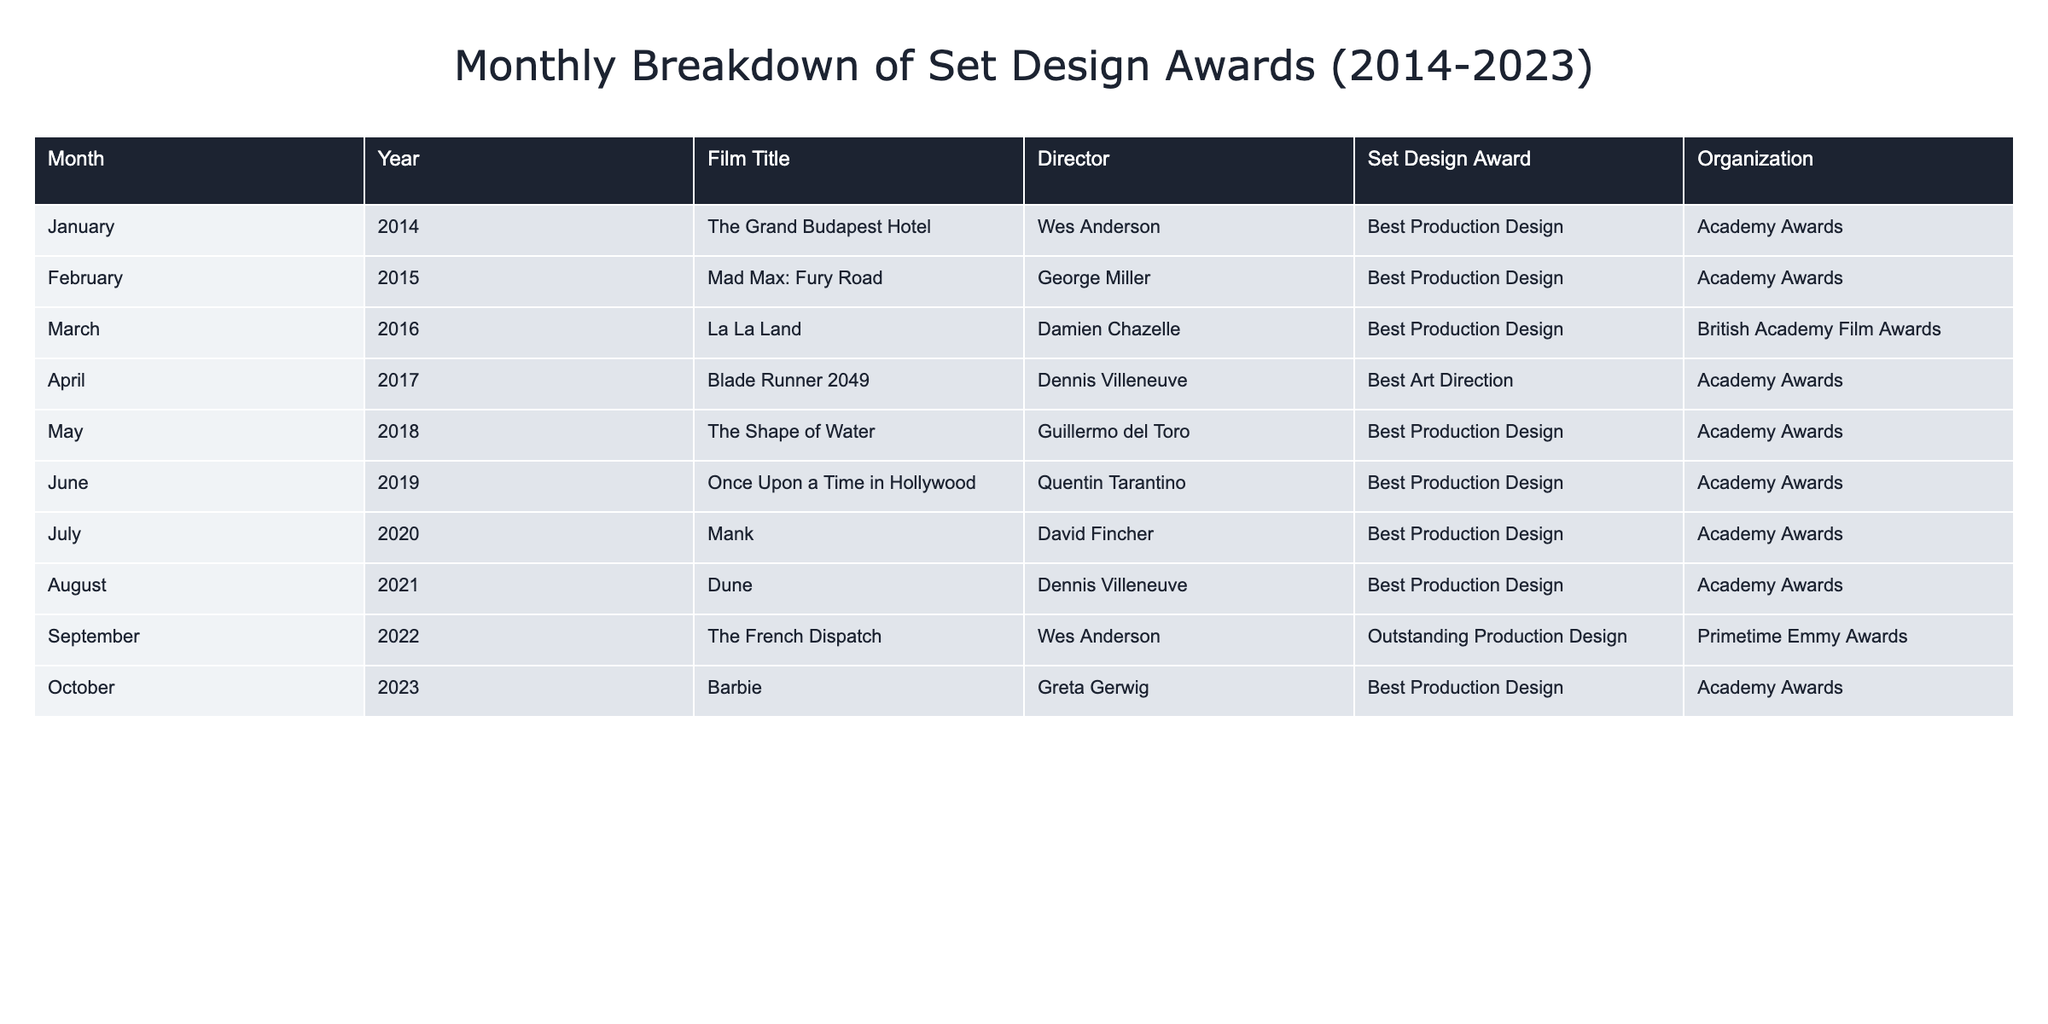What film won the Best Production Design award in February 2015? The table indicates that the film "Mad Max: Fury Road" directed by George Miller won the Best Production Design award in February 2015, according to the Academy Awards.
Answer: Mad Max: Fury Road How many films won set design awards in 2018? From the table, we see that only one film, "The Shape of Water" directed by Guillermo del Toro, won a set design award in 2018, recognized by the Academy Awards.
Answer: 1 Which director has won the most set design awards from the table provided? By reviewing the table, Wes Anderson has won two distinct awards for set design: one for "The Grand Budapest Hotel" in 2014 and another for "The French Dispatch" in 2022. No other director has won more than one award listed in this table.
Answer: Wes Anderson What is the total number of awards won through the Academy Awards for Best Production Design in the last decade? The Academy Awards granted Best Production Design awards to the films "The Grand Budapest Hotel," "Mad Max: Fury Road," "La La Land," "Blade Runner 2049," "The Shape of Water," "Once Upon a Time in Hollywood," "Mank," "Dune," and "Barbie." Counting these gives us eight awards total.
Answer: 8 Was there a set design award given by the Primetime Emmy Awards? Yes, the table shows that "The French Dispatch," directed by Wes Anderson, received the Outstanding Production Design award from the Primetime Emmy Awards in September 2022, indicating that Primetime Emmy Awards do recognize set design.
Answer: Yes What was the latest year represented in the table for the Best Production Design award? The table lists "Barbie," directed by Greta Gerwig, which won the Best Production Design award in October 2023, making it the latest year included in this breakdown.
Answer: 2023 How many different organizations awarded set design awards over the decade? Counting distinct organizations from the table, we see three award bodies: the Academy Awards, the British Academy Film Awards, and the Primetime Emmy Awards. Hence, there are three unique awarding organizations.
Answer: 3 Which film won an award for set design in 2022? The table indicates that "The French Dispatch," directed by Wes Anderson, won the Outstanding Production Design award in September 2022 as recognized by the Primetime Emmy Awards.
Answer: The French Dispatch How many years from 2014 to 2023 did a film win an award for set design? Analyzing the range of years from 2014 to 2023, we find that across all listed years, every year has a corresponding film that won an award for set design, totaling ten years (from 2014 to 2023).
Answer: 10 